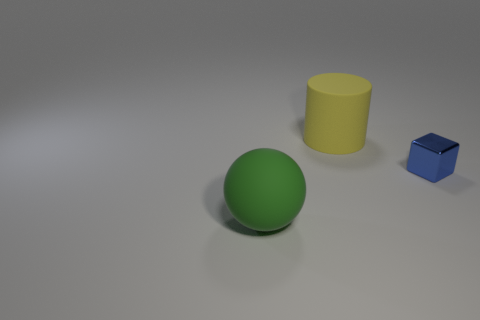Add 1 tiny blue shiny objects. How many objects exist? 4 Subtract all blocks. How many objects are left? 2 Add 1 matte cylinders. How many matte cylinders exist? 2 Subtract 0 gray cubes. How many objects are left? 3 Subtract all blue metal things. Subtract all green objects. How many objects are left? 1 Add 3 yellow cylinders. How many yellow cylinders are left? 4 